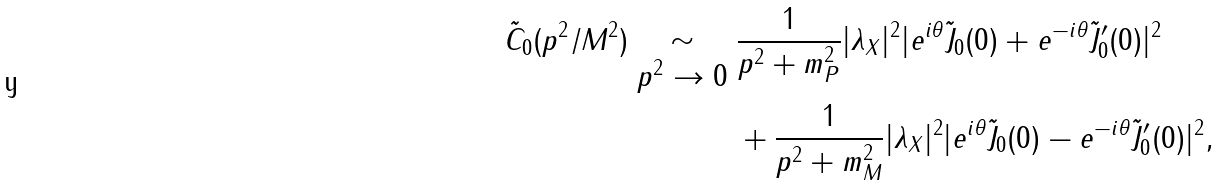<formula> <loc_0><loc_0><loc_500><loc_500>\tilde { C } _ { 0 } ( p ^ { 2 } / M ^ { 2 } ) \begin{array} { c } \\ \sim \\ p ^ { 2 } \rightarrow 0 \end{array} & \frac { 1 } { p ^ { 2 } + m _ { P } ^ { 2 } } | \lambda _ { X } | ^ { 2 } | e ^ { i \theta } \tilde { J } _ { 0 } ( 0 ) + e ^ { - i \theta } \tilde { J } _ { 0 } ^ { \prime } ( 0 ) | ^ { 2 } \\ & + \frac { 1 } { p ^ { 2 } + m _ { M } ^ { 2 } } | \lambda _ { X } | ^ { 2 } | e ^ { i \theta } \tilde { J } _ { 0 } ( 0 ) - e ^ { - i \theta } \tilde { J } _ { 0 } ^ { \prime } ( 0 ) | ^ { 2 } ,</formula> 